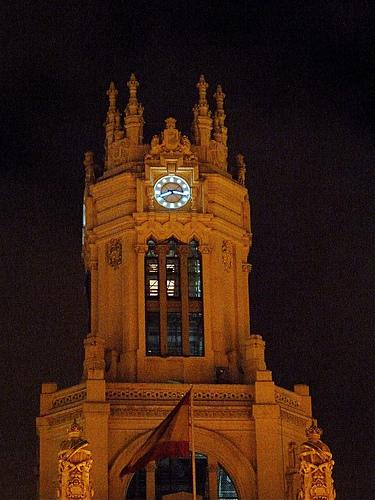Describe the architectural style and materials used in the building. A light brown stone building, featuring arched windows, intricate stone carvings, and a prominent clock tower represents a likely historic architectural style. Summarize the atmosphere and time of day in the image. The image showcases a nighttime scene with dark sky and the clock tower and its features illuminated, creating a beautiful atmosphere. How many primary colors are present on the flag and what are they? There are two primary colors on the flag: red and yellow. Elaborate on the design of the large clock on the tower. The large clock on the tower has a white illuminated face, black numbers, and two hands - a small hand and a large hand. Examine the decoration on top of the tower and provide a brief description. The decoration on top of the tower includes pointed structures, crown structures near the flag, and elaborate stone carvings. Deliver a brief sentiment analysis of the image. The image evokes a sense of mystery and beauty due to the nighttime setting, the illuminated clock tower, and the ornate architectural details. What type of flag is in front of the building and describe its colors and pattern. In front of the building, there is a red and yellow striped flag. Mention the primary object and its features in the image. An ornate decorative clock tower with a large illuminated clock, pointed structures at the top, and intricate carvings is the primary object in the image. Determine how many windows are located below the clock on the tower. There are two windows with pointed tops right below the clock on the tower. Provide a count of the visible numbers on the clock face in the image. There are 9 visible numbers on the clock face. Is the sky filled with bright stars and a full moon? The sky is mentioned as "night sky above tower," "black sky," and "empty night sky," but there is no mention of stars or a full moon in the sky. Describe the top part of the building with the pointed structures. Ornately carved top of the building with pointed structures on the edge of the tower's top. What is the color of the night sky outside the building? Black How does the night sky look above the tower? Empty Describe the flag's banner and pole colors. The banner is red and white striped, and the pole is white painted metal. Can you find the number 7 on the clock? The numbers 1, 2, 3, 4, 5, 6, 9, and 12 are mentioned on the clock, but there is no mention of the number 7. What is the expression at the Buddha decoration on the building? Not applicable, as expressions cannot be determined for this case. What type of flag is in front of the building? Red and white striped flag. Is the flag in front of the building blue and green with a star pattern? No, it's not mentioned in the image. Which structure can be seen right below the clock tower in the image? Windows with pointed tops. Describe the position of the small hand and the large hand on the clock. The small hand points to 4, and the large hand points to 9. At what time does the clock show? The clock reads about 4:45 Which number is being illuminated in the clock tower? 12 What material does the building seem to be made of? Light brown stone Based on the image, suggest a possible current event. A nighttime gathering or celebration near the flag. Describe the decoration border on the building using the elements present in the image. Ornately carved stone with intricate details. Given these options, can you identify the architectural element present in the flag's location? A) Arched window, B) Pointed roof, or C) Decorative columns A) Arched window What is the appearance of the windows right below the clock? They have pointed tops and black frames. Does the tower have circular windows on top? The windows on the tower are described as "windows with pointed tops" or "arched windows", not circular windows. What type of windows are located near the bottom of the building? Arched windows What is the overall style of the building and its decoration? Ornate and decorative, with a clock tower and intricate detailing. What is the color combination of the flag present in the image? Red and white striped 